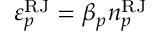Convert formula to latex. <formula><loc_0><loc_0><loc_500><loc_500>\varepsilon _ { p } ^ { R J } = \beta _ { p } n _ { p } ^ { R J }</formula> 